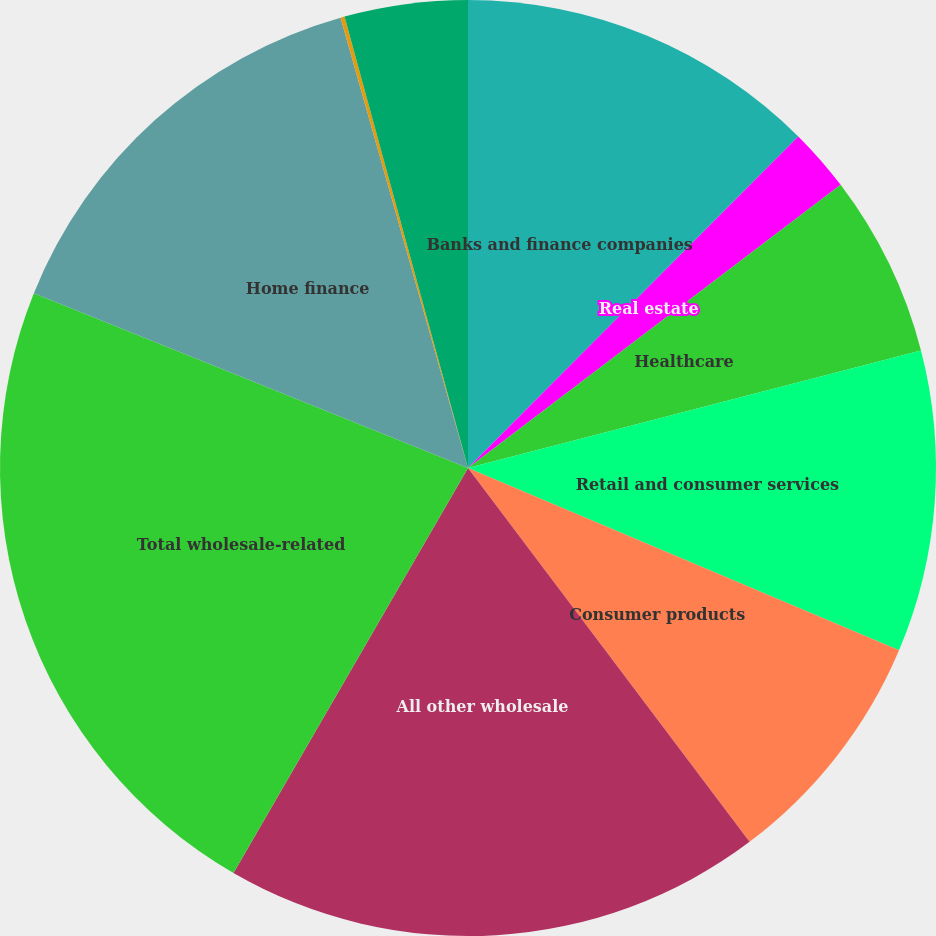Convert chart. <chart><loc_0><loc_0><loc_500><loc_500><pie_chart><fcel>Banks and finance companies<fcel>Real estate<fcel>Healthcare<fcel>Retail and consumer services<fcel>Consumer products<fcel>All other wholesale<fcel>Total wholesale-related<fcel>Home finance<fcel>Auto & education finance<fcel>Consumer & small business and<nl><fcel>12.47%<fcel>2.19%<fcel>6.3%<fcel>10.41%<fcel>8.36%<fcel>18.63%<fcel>22.74%<fcel>14.52%<fcel>0.14%<fcel>4.25%<nl></chart> 